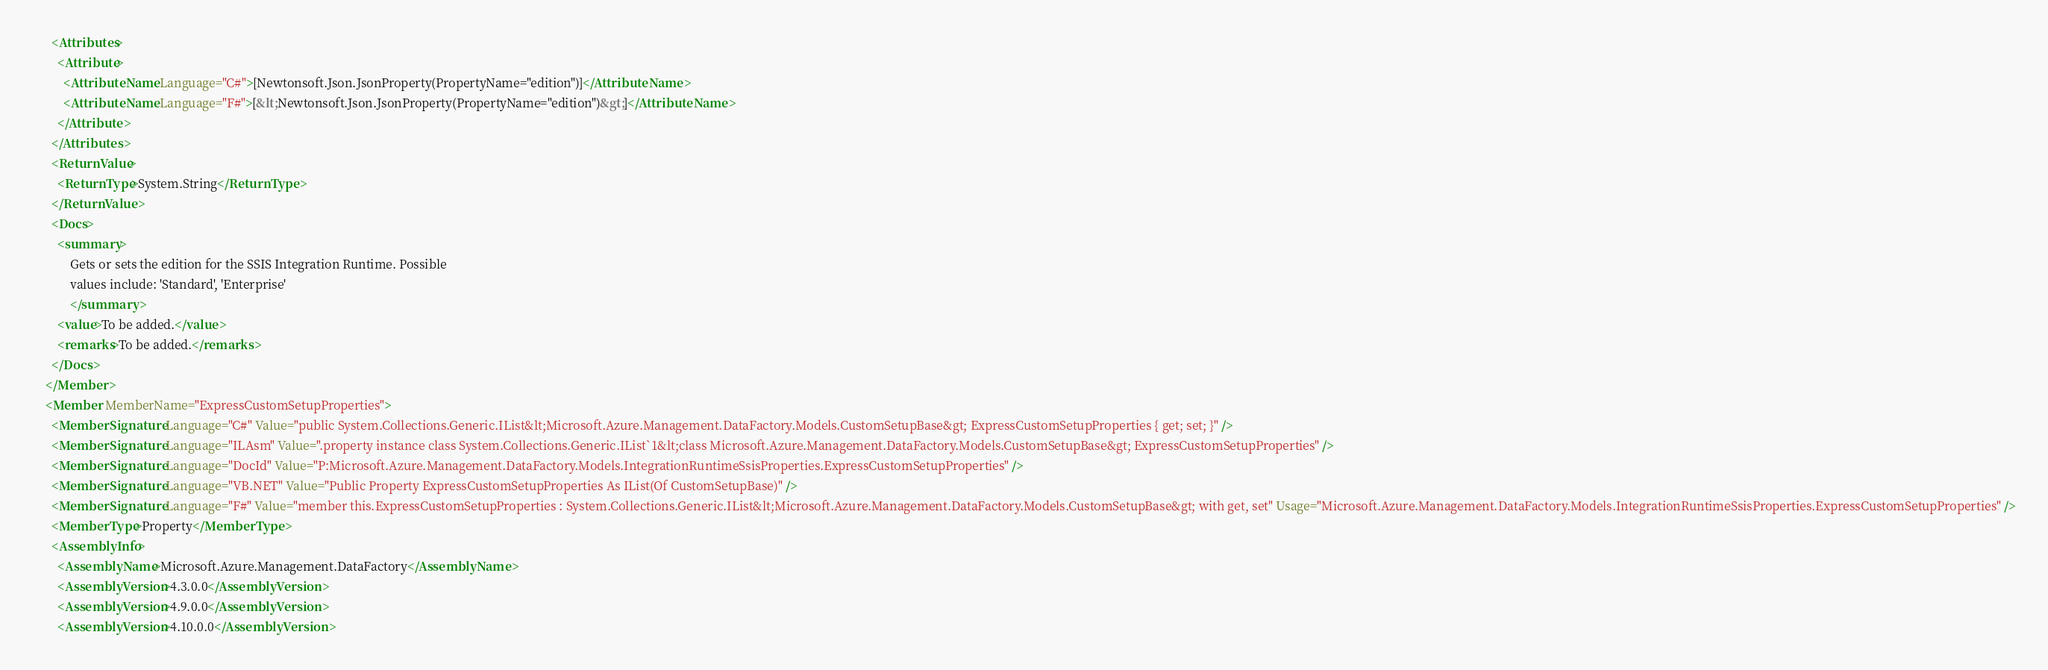Convert code to text. <code><loc_0><loc_0><loc_500><loc_500><_XML_>      <Attributes>
        <Attribute>
          <AttributeName Language="C#">[Newtonsoft.Json.JsonProperty(PropertyName="edition")]</AttributeName>
          <AttributeName Language="F#">[&lt;Newtonsoft.Json.JsonProperty(PropertyName="edition")&gt;]</AttributeName>
        </Attribute>
      </Attributes>
      <ReturnValue>
        <ReturnType>System.String</ReturnType>
      </ReturnValue>
      <Docs>
        <summary>
            Gets or sets the edition for the SSIS Integration Runtime. Possible
            values include: 'Standard', 'Enterprise'
            </summary>
        <value>To be added.</value>
        <remarks>To be added.</remarks>
      </Docs>
    </Member>
    <Member MemberName="ExpressCustomSetupProperties">
      <MemberSignature Language="C#" Value="public System.Collections.Generic.IList&lt;Microsoft.Azure.Management.DataFactory.Models.CustomSetupBase&gt; ExpressCustomSetupProperties { get; set; }" />
      <MemberSignature Language="ILAsm" Value=".property instance class System.Collections.Generic.IList`1&lt;class Microsoft.Azure.Management.DataFactory.Models.CustomSetupBase&gt; ExpressCustomSetupProperties" />
      <MemberSignature Language="DocId" Value="P:Microsoft.Azure.Management.DataFactory.Models.IntegrationRuntimeSsisProperties.ExpressCustomSetupProperties" />
      <MemberSignature Language="VB.NET" Value="Public Property ExpressCustomSetupProperties As IList(Of CustomSetupBase)" />
      <MemberSignature Language="F#" Value="member this.ExpressCustomSetupProperties : System.Collections.Generic.IList&lt;Microsoft.Azure.Management.DataFactory.Models.CustomSetupBase&gt; with get, set" Usage="Microsoft.Azure.Management.DataFactory.Models.IntegrationRuntimeSsisProperties.ExpressCustomSetupProperties" />
      <MemberType>Property</MemberType>
      <AssemblyInfo>
        <AssemblyName>Microsoft.Azure.Management.DataFactory</AssemblyName>
        <AssemblyVersion>4.3.0.0</AssemblyVersion>
        <AssemblyVersion>4.9.0.0</AssemblyVersion>
        <AssemblyVersion>4.10.0.0</AssemblyVersion></code> 